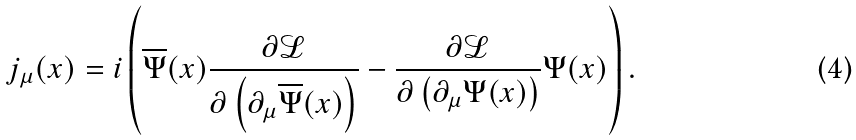<formula> <loc_0><loc_0><loc_500><loc_500>j _ { \mu } ( x ) = i \left ( \overline { \Psi } ( x ) \frac { \partial \mathcal { L } } { \partial \left ( \partial _ { \mu } \overline { \Psi } ( x ) \right ) } - \frac { \partial \mathcal { L } } { \partial \left ( \partial _ { \mu } \Psi ( x ) \right ) } \Psi ( x ) \right ) .</formula> 